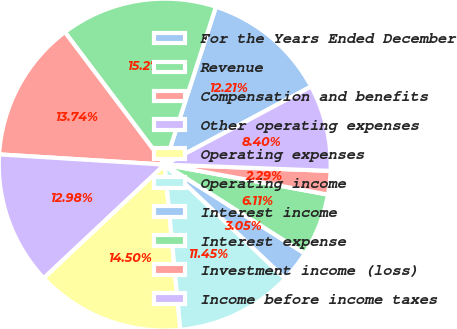Convert chart to OTSL. <chart><loc_0><loc_0><loc_500><loc_500><pie_chart><fcel>For the Years Ended December<fcel>Revenue<fcel>Compensation and benefits<fcel>Other operating expenses<fcel>Operating expenses<fcel>Operating income<fcel>Interest income<fcel>Interest expense<fcel>Investment income (loss)<fcel>Income before income taxes<nl><fcel>12.21%<fcel>15.27%<fcel>13.74%<fcel>12.98%<fcel>14.5%<fcel>11.45%<fcel>3.05%<fcel>6.11%<fcel>2.29%<fcel>8.4%<nl></chart> 